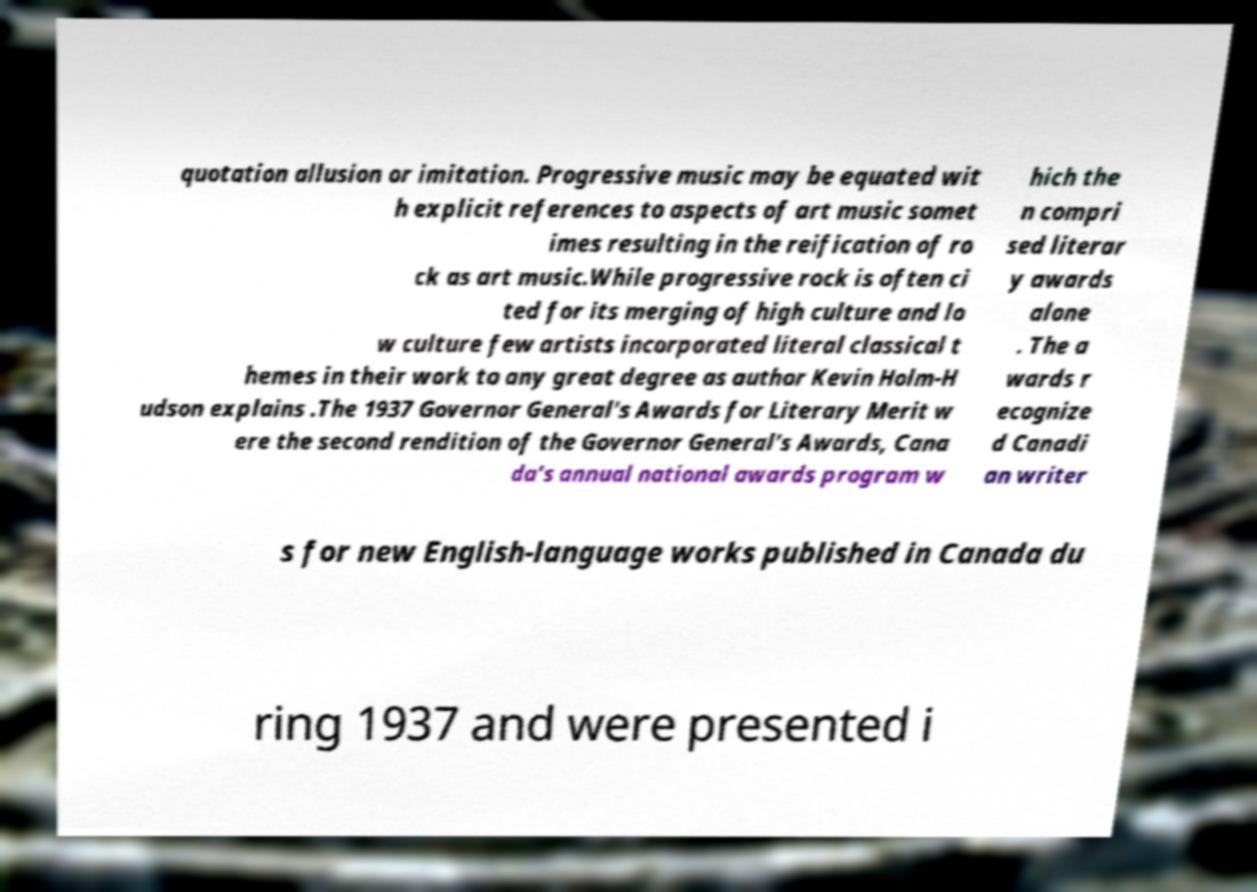Please identify and transcribe the text found in this image. quotation allusion or imitation. Progressive music may be equated wit h explicit references to aspects of art music somet imes resulting in the reification of ro ck as art music.While progressive rock is often ci ted for its merging of high culture and lo w culture few artists incorporated literal classical t hemes in their work to any great degree as author Kevin Holm-H udson explains .The 1937 Governor General's Awards for Literary Merit w ere the second rendition of the Governor General's Awards, Cana da's annual national awards program w hich the n compri sed literar y awards alone . The a wards r ecognize d Canadi an writer s for new English-language works published in Canada du ring 1937 and were presented i 